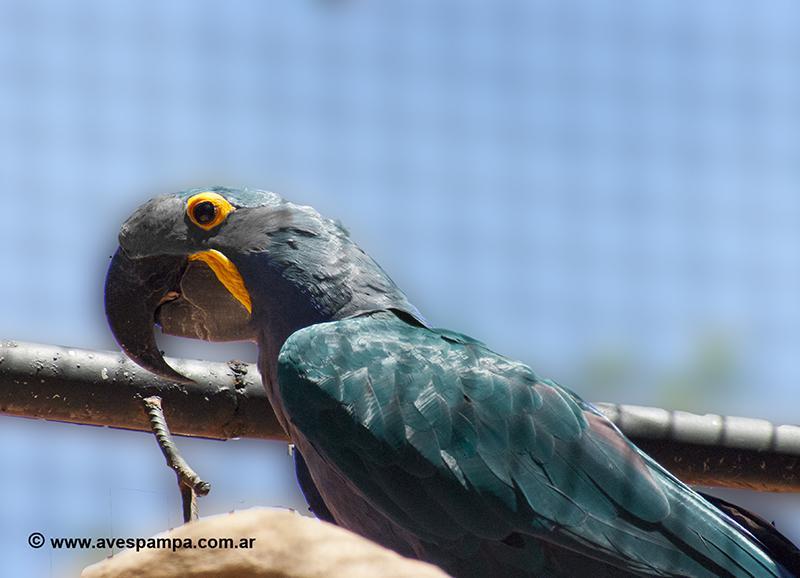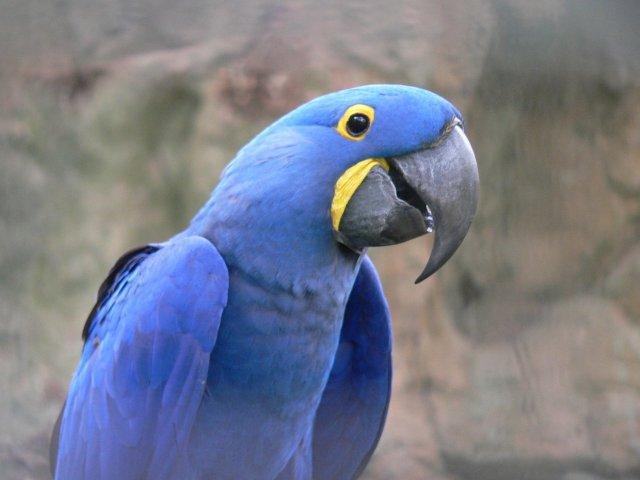The first image is the image on the left, the second image is the image on the right. Examine the images to the left and right. Is the description "There is exactly one bird in the image on the right." accurate? Answer yes or no. Yes. 